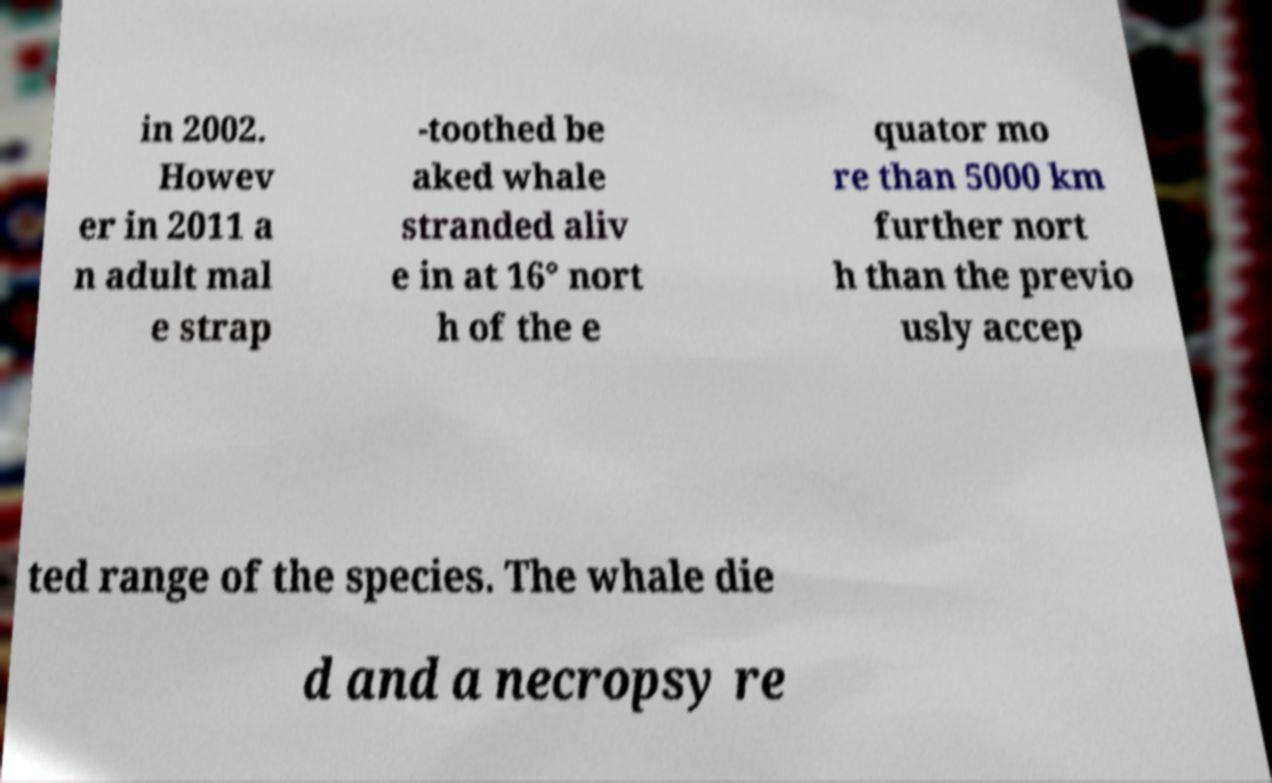Can you accurately transcribe the text from the provided image for me? in 2002. Howev er in 2011 a n adult mal e strap -toothed be aked whale stranded aliv e in at 16° nort h of the e quator mo re than 5000 km further nort h than the previo usly accep ted range of the species. The whale die d and a necropsy re 